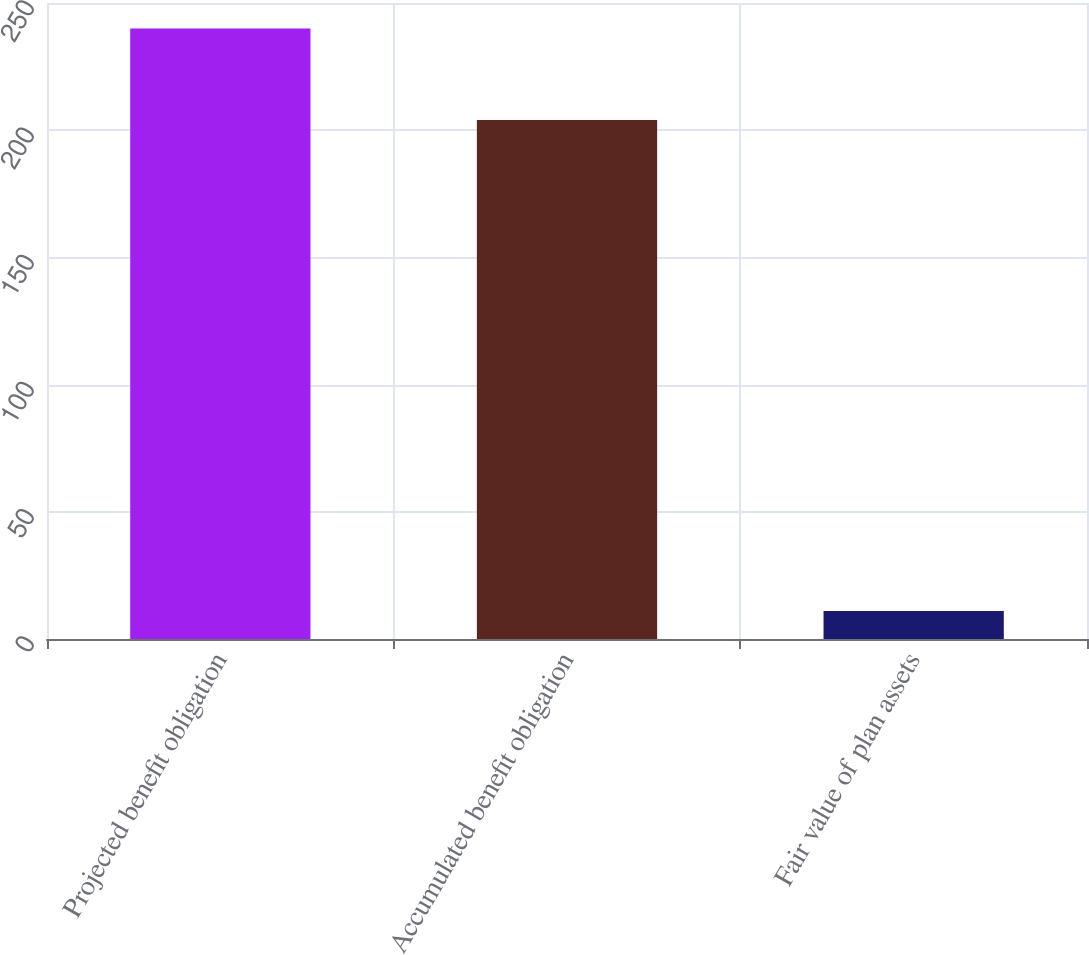<chart> <loc_0><loc_0><loc_500><loc_500><bar_chart><fcel>Projected benefit obligation<fcel>Accumulated benefit obligation<fcel>Fair value of plan assets<nl><fcel>240<fcel>204<fcel>11<nl></chart> 